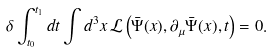<formula> <loc_0><loc_0><loc_500><loc_500>\delta \int _ { t _ { 0 } } ^ { t _ { 1 } } d t \int d ^ { 3 } x \, \mathcal { L } \left ( \bar { \Psi } ( x ) , \partial _ { \mu } \bar { \Psi } ( x ) , t \right ) = 0 .</formula> 